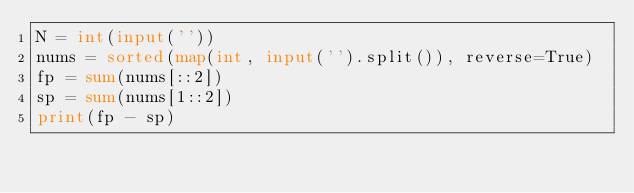<code> <loc_0><loc_0><loc_500><loc_500><_Python_>N = int(input(''))
nums = sorted(map(int, input('').split()), reverse=True)
fp = sum(nums[::2])
sp = sum(nums[1::2])
print(fp - sp)

</code> 